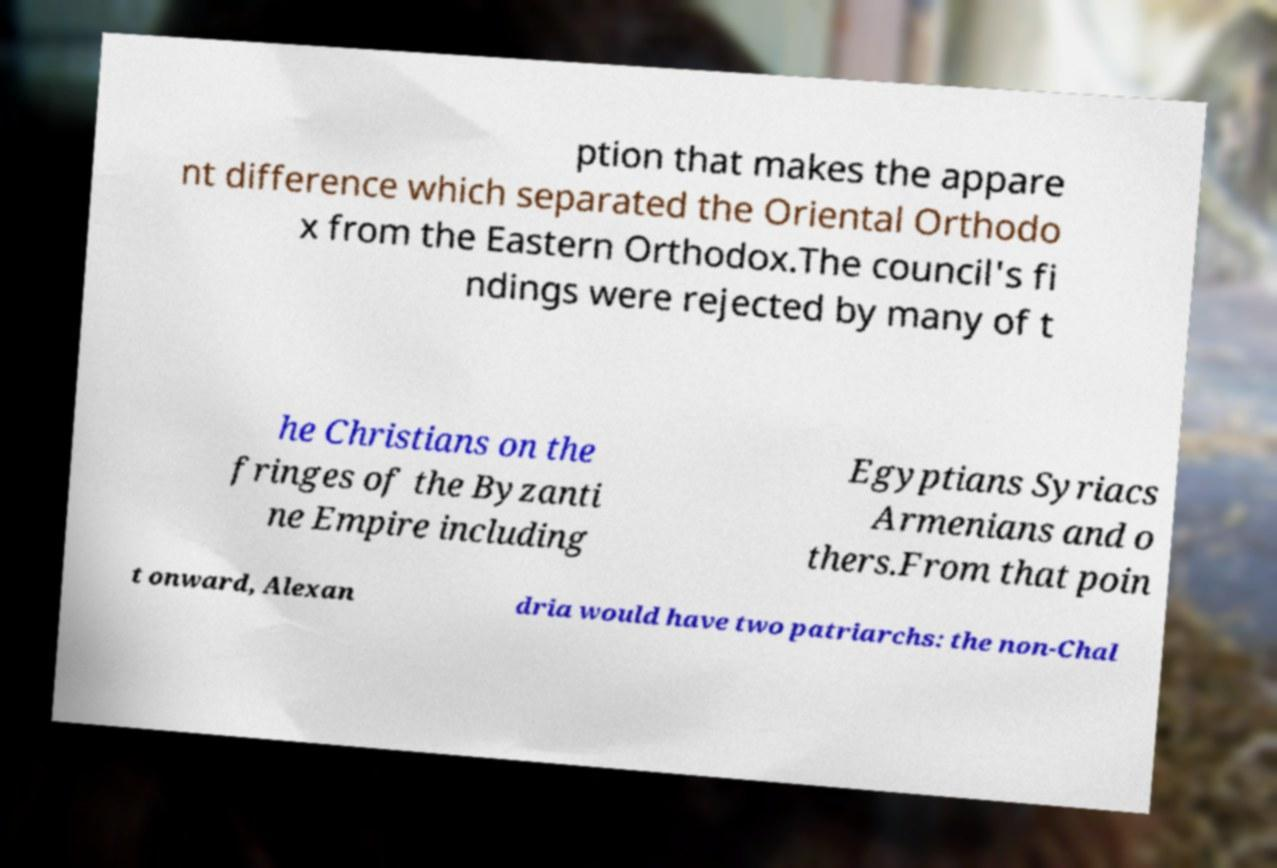Can you accurately transcribe the text from the provided image for me? ption that makes the appare nt difference which separated the Oriental Orthodo x from the Eastern Orthodox.The council's fi ndings were rejected by many of t he Christians on the fringes of the Byzanti ne Empire including Egyptians Syriacs Armenians and o thers.From that poin t onward, Alexan dria would have two patriarchs: the non-Chal 